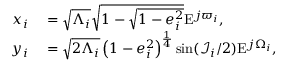Convert formula to latex. <formula><loc_0><loc_0><loc_500><loc_500>\begin{array} { r l } { x _ { i } } & = \sqrt { \Lambda _ { i } } \sqrt { 1 - \sqrt { 1 - e _ { i } ^ { 2 } } } E ^ { j \varpi _ { i } } , } \\ { y _ { i } } & = \sqrt { 2 \Lambda _ { i } } \left ( 1 - e _ { i } ^ { 2 } \right ) ^ { \frac { 1 } { 4 } } \sin ( \mathcal { I } _ { i } / 2 ) E ^ { j \Omega _ { i } } , } \end{array}</formula> 